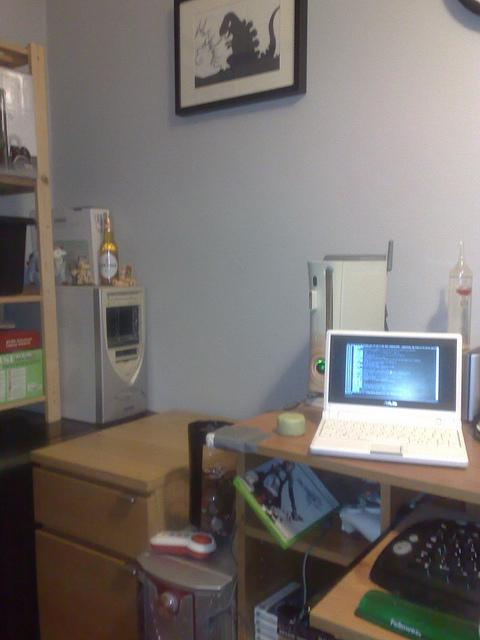What kind of beverage is sat atop of the computer tower in the corner of this room? Please explain your reasoning. beer. The beverage is beer. 